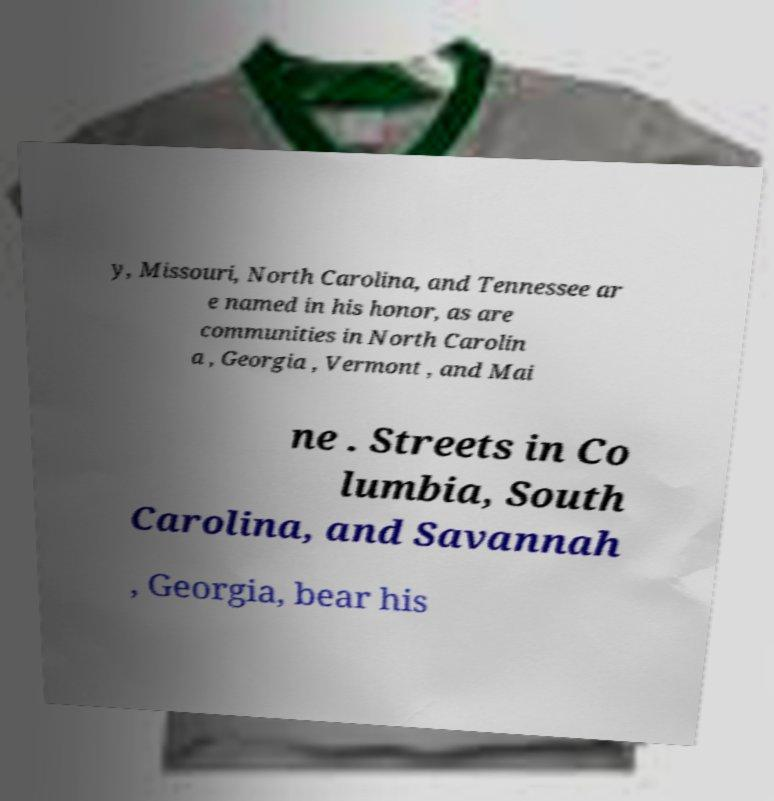Could you assist in decoding the text presented in this image and type it out clearly? y, Missouri, North Carolina, and Tennessee ar e named in his honor, as are communities in North Carolin a , Georgia , Vermont , and Mai ne . Streets in Co lumbia, South Carolina, and Savannah , Georgia, bear his 